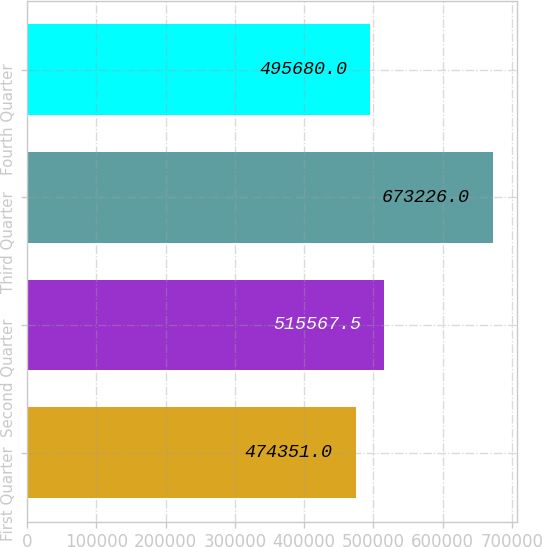Convert chart. <chart><loc_0><loc_0><loc_500><loc_500><bar_chart><fcel>First Quarter<fcel>Second Quarter<fcel>Third Quarter<fcel>Fourth Quarter<nl><fcel>474351<fcel>515568<fcel>673226<fcel>495680<nl></chart> 